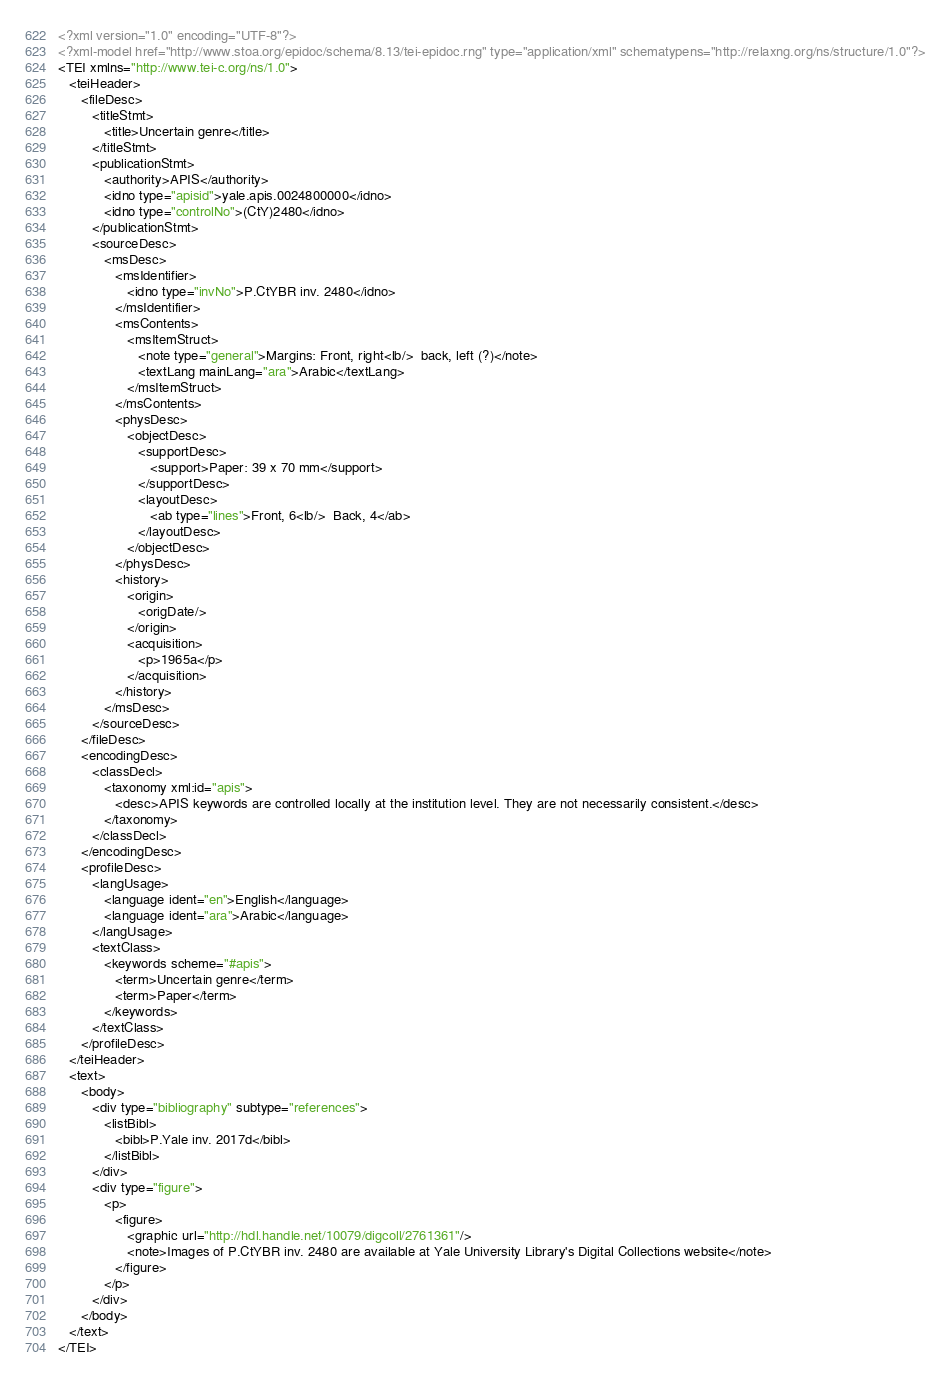Convert code to text. <code><loc_0><loc_0><loc_500><loc_500><_XML_><?xml version="1.0" encoding="UTF-8"?>
<?xml-model href="http://www.stoa.org/epidoc/schema/8.13/tei-epidoc.rng" type="application/xml" schematypens="http://relaxng.org/ns/structure/1.0"?>
<TEI xmlns="http://www.tei-c.org/ns/1.0">
   <teiHeader>
      <fileDesc>
         <titleStmt>
            <title>Uncertain genre</title>
         </titleStmt>
         <publicationStmt>
            <authority>APIS</authority>
            <idno type="apisid">yale.apis.0024800000</idno>
            <idno type="controlNo">(CtY)2480</idno>
         </publicationStmt>
         <sourceDesc>
            <msDesc>
               <msIdentifier>
                  <idno type="invNo">P.CtYBR inv. 2480</idno>
               </msIdentifier>
               <msContents>
                  <msItemStruct>
                     <note type="general">Margins: Front, right<lb/>  back, left (?)</note>
                     <textLang mainLang="ara">Arabic</textLang>
                  </msItemStruct>
               </msContents>
               <physDesc>
                  <objectDesc>
                     <supportDesc>
                        <support>Paper: 39 x 70 mm</support>
                     </supportDesc>
                     <layoutDesc>
                        <ab type="lines">Front, 6<lb/>  Back, 4</ab>
                     </layoutDesc>
                  </objectDesc>
               </physDesc>
               <history>
                  <origin>
                     <origDate/>
                  </origin>
                  <acquisition>
                     <p>1965a</p>
                  </acquisition>
               </history>
            </msDesc>
         </sourceDesc>
      </fileDesc>
      <encodingDesc>
         <classDecl>
            <taxonomy xml:id="apis">
               <desc>APIS keywords are controlled locally at the institution level. They are not necessarily consistent.</desc>
            </taxonomy>
         </classDecl>
      </encodingDesc>
      <profileDesc>
         <langUsage>
            <language ident="en">English</language>
            <language ident="ara">Arabic</language>
         </langUsage>
         <textClass>
            <keywords scheme="#apis">
               <term>Uncertain genre</term>
               <term>Paper</term>
            </keywords>
         </textClass>
      </profileDesc>
   </teiHeader>
   <text>
      <body>
         <div type="bibliography" subtype="references">
            <listBibl>
               <bibl>P.Yale inv. 2017d</bibl>
            </listBibl>
         </div>
         <div type="figure">
            <p>
               <figure>
                  <graphic url="http://hdl.handle.net/10079/digcoll/2761361"/>
                  <note>Images of P.CtYBR inv. 2480 are available at Yale University Library's Digital Collections website</note>
               </figure>
            </p>
         </div>
      </body>
   </text>
</TEI>
</code> 